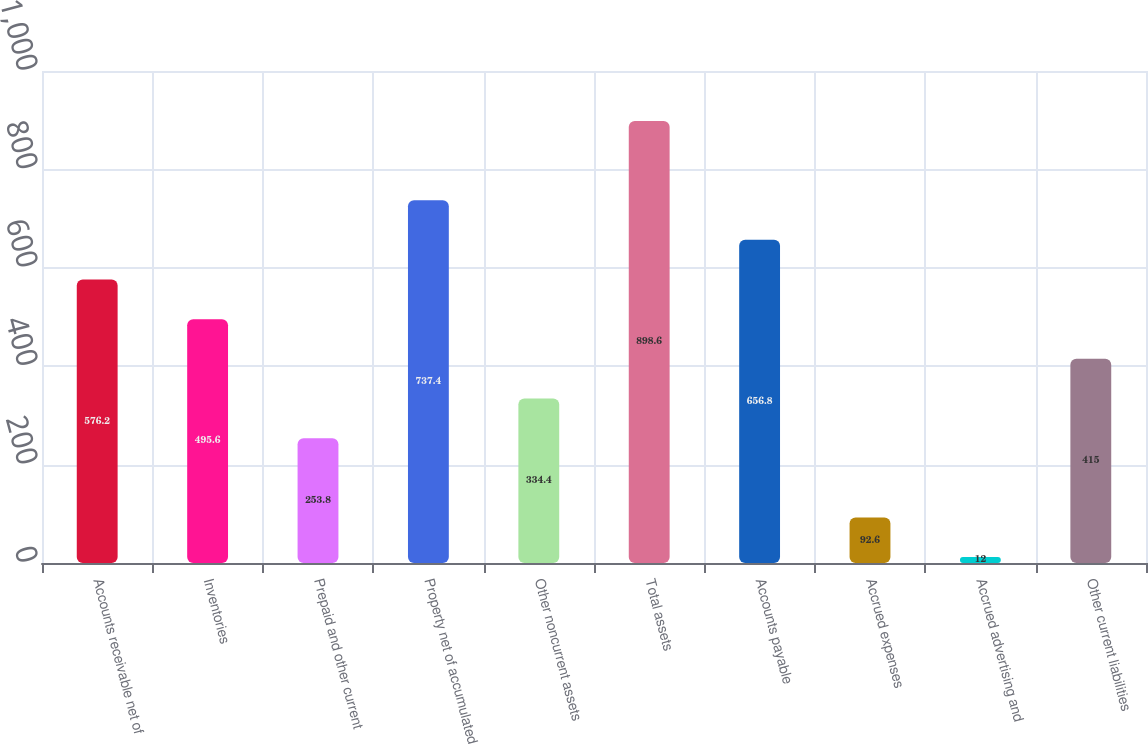<chart> <loc_0><loc_0><loc_500><loc_500><bar_chart><fcel>Accounts receivable net of<fcel>Inventories<fcel>Prepaid and other current<fcel>Property net of accumulated<fcel>Other noncurrent assets<fcel>Total assets<fcel>Accounts payable<fcel>Accrued expenses<fcel>Accrued advertising and<fcel>Other current liabilities<nl><fcel>576.2<fcel>495.6<fcel>253.8<fcel>737.4<fcel>334.4<fcel>898.6<fcel>656.8<fcel>92.6<fcel>12<fcel>415<nl></chart> 